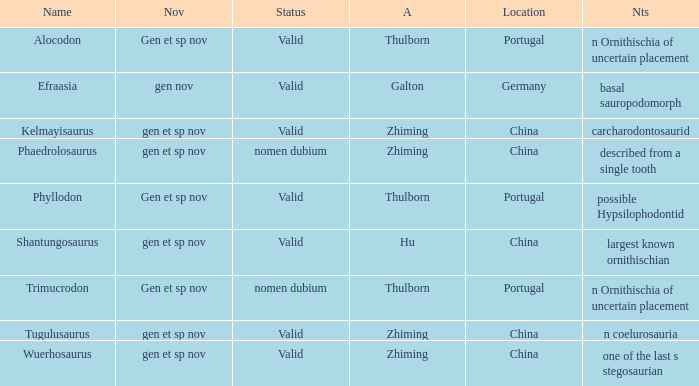What are the Notes of the dinosaur, whose Status is nomen dubium, and whose Location is China? Described from a single tooth. 